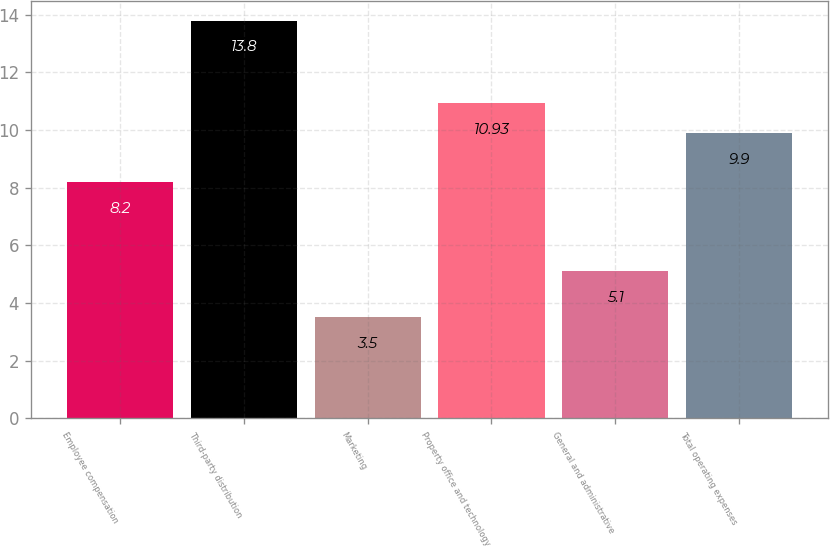<chart> <loc_0><loc_0><loc_500><loc_500><bar_chart><fcel>Employee compensation<fcel>Third-party distribution<fcel>Marketing<fcel>Property office and technology<fcel>General and administrative<fcel>Total operating expenses<nl><fcel>8.2<fcel>13.8<fcel>3.5<fcel>10.93<fcel>5.1<fcel>9.9<nl></chart> 